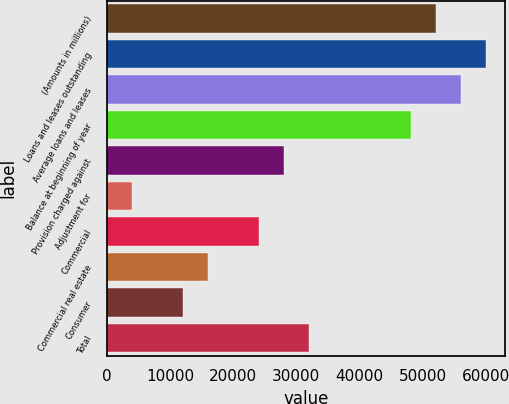Convert chart to OTSL. <chart><loc_0><loc_0><loc_500><loc_500><bar_chart><fcel>(Amounts in millions)<fcel>Loans and leases outstanding<fcel>Average loans and leases<fcel>Balance at beginning of year<fcel>Provision charged against<fcel>Adjustment for<fcel>Commercial<fcel>Commercial real estate<fcel>Consumer<fcel>Total<nl><fcel>52083.2<fcel>60096<fcel>56089.6<fcel>48076.8<fcel>28044.8<fcel>4006.5<fcel>24038.5<fcel>16025.7<fcel>12019.3<fcel>32051.2<nl></chart> 